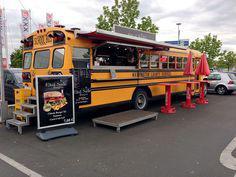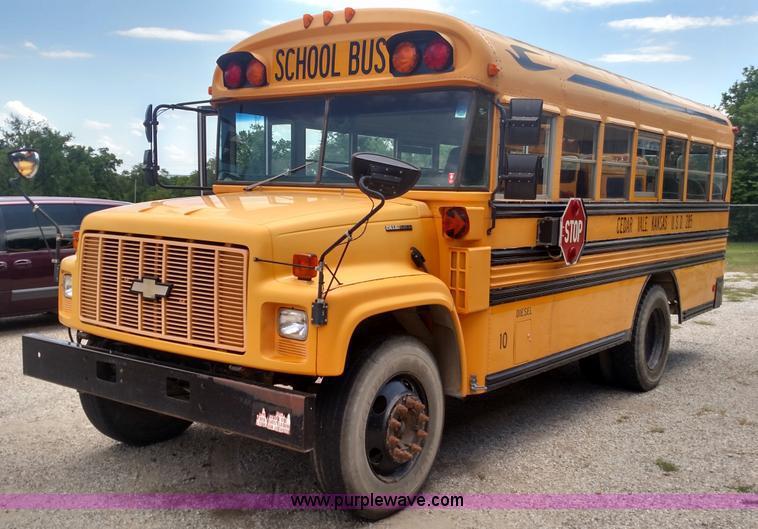The first image is the image on the left, the second image is the image on the right. Considering the images on both sides, is "One of the buses is a traditional yellow color while the other is more of a reddish hue." valid? Answer yes or no. No. The first image is the image on the left, the second image is the image on the right. Assess this claim about the two images: "The right image contains a red-orange bus angled facing rightward.". Correct or not? Answer yes or no. No. 